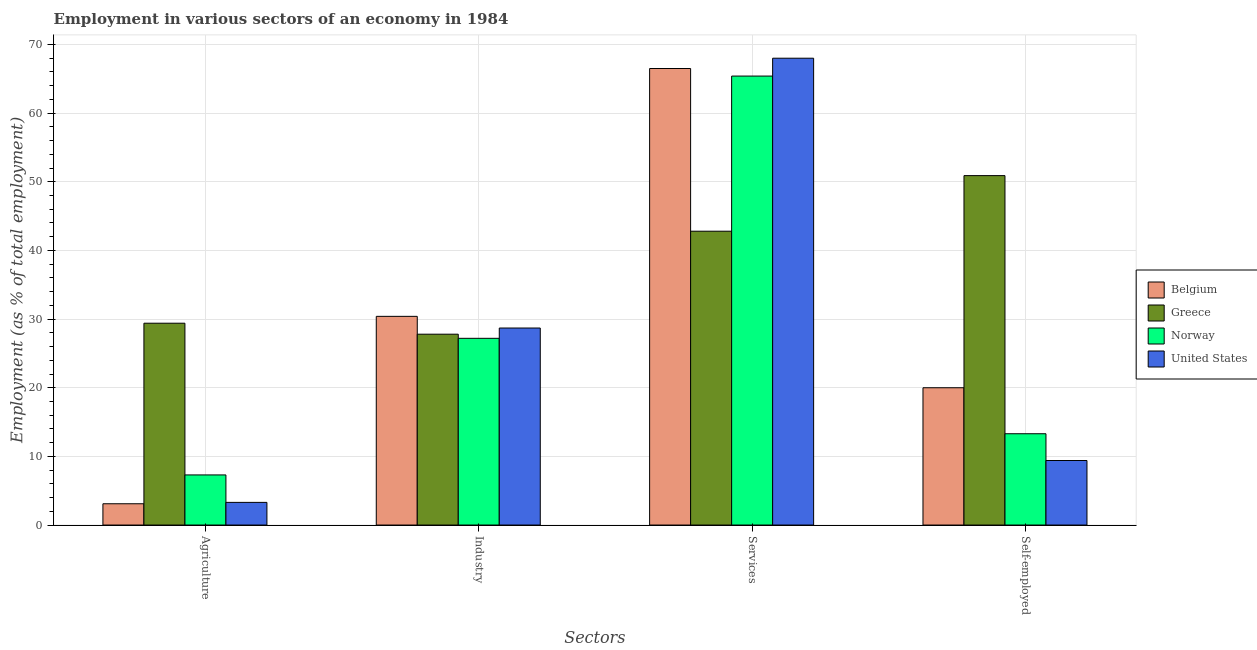How many different coloured bars are there?
Provide a succinct answer. 4. How many groups of bars are there?
Give a very brief answer. 4. Are the number of bars on each tick of the X-axis equal?
Your response must be concise. Yes. What is the label of the 2nd group of bars from the left?
Your answer should be compact. Industry. What is the percentage of workers in industry in Norway?
Your answer should be compact. 27.2. Across all countries, what is the maximum percentage of workers in industry?
Your answer should be compact. 30.4. Across all countries, what is the minimum percentage of self employed workers?
Your answer should be compact. 9.4. In which country was the percentage of workers in agriculture maximum?
Provide a succinct answer. Greece. In which country was the percentage of self employed workers minimum?
Provide a succinct answer. United States. What is the total percentage of workers in industry in the graph?
Your answer should be compact. 114.1. What is the difference between the percentage of workers in services in United States and that in Greece?
Keep it short and to the point. 25.2. What is the difference between the percentage of workers in industry in Norway and the percentage of workers in services in United States?
Your response must be concise. -40.8. What is the average percentage of workers in services per country?
Your response must be concise. 60.68. What is the difference between the percentage of workers in agriculture and percentage of workers in services in Norway?
Give a very brief answer. -58.1. What is the ratio of the percentage of workers in services in United States to that in Greece?
Provide a short and direct response. 1.59. Is the difference between the percentage of workers in agriculture in Norway and United States greater than the difference between the percentage of workers in services in Norway and United States?
Your response must be concise. Yes. What is the difference between the highest and the second highest percentage of workers in agriculture?
Keep it short and to the point. 22.1. What is the difference between the highest and the lowest percentage of workers in services?
Make the answer very short. 25.2. In how many countries, is the percentage of workers in agriculture greater than the average percentage of workers in agriculture taken over all countries?
Offer a terse response. 1. Is the sum of the percentage of workers in agriculture in United States and Norway greater than the maximum percentage of workers in services across all countries?
Give a very brief answer. No. What does the 2nd bar from the left in Agriculture represents?
Ensure brevity in your answer.  Greece. Is it the case that in every country, the sum of the percentage of workers in agriculture and percentage of workers in industry is greater than the percentage of workers in services?
Your answer should be very brief. No. Are all the bars in the graph horizontal?
Give a very brief answer. No. What is the difference between two consecutive major ticks on the Y-axis?
Keep it short and to the point. 10. Are the values on the major ticks of Y-axis written in scientific E-notation?
Offer a very short reply. No. Does the graph contain grids?
Offer a very short reply. Yes. Where does the legend appear in the graph?
Ensure brevity in your answer.  Center right. How many legend labels are there?
Your answer should be very brief. 4. What is the title of the graph?
Provide a short and direct response. Employment in various sectors of an economy in 1984. Does "Nicaragua" appear as one of the legend labels in the graph?
Your answer should be compact. No. What is the label or title of the X-axis?
Ensure brevity in your answer.  Sectors. What is the label or title of the Y-axis?
Offer a terse response. Employment (as % of total employment). What is the Employment (as % of total employment) in Belgium in Agriculture?
Provide a succinct answer. 3.1. What is the Employment (as % of total employment) in Greece in Agriculture?
Ensure brevity in your answer.  29.4. What is the Employment (as % of total employment) of Norway in Agriculture?
Your answer should be very brief. 7.3. What is the Employment (as % of total employment) in United States in Agriculture?
Provide a succinct answer. 3.3. What is the Employment (as % of total employment) of Belgium in Industry?
Your answer should be very brief. 30.4. What is the Employment (as % of total employment) of Greece in Industry?
Keep it short and to the point. 27.8. What is the Employment (as % of total employment) of Norway in Industry?
Provide a succinct answer. 27.2. What is the Employment (as % of total employment) of United States in Industry?
Make the answer very short. 28.7. What is the Employment (as % of total employment) in Belgium in Services?
Provide a succinct answer. 66.5. What is the Employment (as % of total employment) of Greece in Services?
Provide a succinct answer. 42.8. What is the Employment (as % of total employment) of Norway in Services?
Your answer should be compact. 65.4. What is the Employment (as % of total employment) in United States in Services?
Your response must be concise. 68. What is the Employment (as % of total employment) of Belgium in Self-employed?
Give a very brief answer. 20. What is the Employment (as % of total employment) of Greece in Self-employed?
Make the answer very short. 50.9. What is the Employment (as % of total employment) of Norway in Self-employed?
Your answer should be very brief. 13.3. What is the Employment (as % of total employment) of United States in Self-employed?
Provide a succinct answer. 9.4. Across all Sectors, what is the maximum Employment (as % of total employment) of Belgium?
Give a very brief answer. 66.5. Across all Sectors, what is the maximum Employment (as % of total employment) of Greece?
Make the answer very short. 50.9. Across all Sectors, what is the maximum Employment (as % of total employment) of Norway?
Your answer should be very brief. 65.4. Across all Sectors, what is the minimum Employment (as % of total employment) of Belgium?
Ensure brevity in your answer.  3.1. Across all Sectors, what is the minimum Employment (as % of total employment) of Greece?
Offer a terse response. 27.8. Across all Sectors, what is the minimum Employment (as % of total employment) in Norway?
Offer a terse response. 7.3. Across all Sectors, what is the minimum Employment (as % of total employment) of United States?
Offer a terse response. 3.3. What is the total Employment (as % of total employment) of Belgium in the graph?
Ensure brevity in your answer.  120. What is the total Employment (as % of total employment) of Greece in the graph?
Provide a succinct answer. 150.9. What is the total Employment (as % of total employment) in Norway in the graph?
Your response must be concise. 113.2. What is the total Employment (as % of total employment) in United States in the graph?
Make the answer very short. 109.4. What is the difference between the Employment (as % of total employment) of Belgium in Agriculture and that in Industry?
Offer a very short reply. -27.3. What is the difference between the Employment (as % of total employment) of Norway in Agriculture and that in Industry?
Your response must be concise. -19.9. What is the difference between the Employment (as % of total employment) of United States in Agriculture and that in Industry?
Your answer should be very brief. -25.4. What is the difference between the Employment (as % of total employment) in Belgium in Agriculture and that in Services?
Provide a succinct answer. -63.4. What is the difference between the Employment (as % of total employment) of Greece in Agriculture and that in Services?
Your answer should be very brief. -13.4. What is the difference between the Employment (as % of total employment) in Norway in Agriculture and that in Services?
Your response must be concise. -58.1. What is the difference between the Employment (as % of total employment) of United States in Agriculture and that in Services?
Provide a short and direct response. -64.7. What is the difference between the Employment (as % of total employment) in Belgium in Agriculture and that in Self-employed?
Give a very brief answer. -16.9. What is the difference between the Employment (as % of total employment) in Greece in Agriculture and that in Self-employed?
Offer a terse response. -21.5. What is the difference between the Employment (as % of total employment) in Belgium in Industry and that in Services?
Your response must be concise. -36.1. What is the difference between the Employment (as % of total employment) of Norway in Industry and that in Services?
Keep it short and to the point. -38.2. What is the difference between the Employment (as % of total employment) in United States in Industry and that in Services?
Ensure brevity in your answer.  -39.3. What is the difference between the Employment (as % of total employment) in Belgium in Industry and that in Self-employed?
Offer a very short reply. 10.4. What is the difference between the Employment (as % of total employment) of Greece in Industry and that in Self-employed?
Your answer should be compact. -23.1. What is the difference between the Employment (as % of total employment) of Norway in Industry and that in Self-employed?
Offer a very short reply. 13.9. What is the difference between the Employment (as % of total employment) in United States in Industry and that in Self-employed?
Provide a succinct answer. 19.3. What is the difference between the Employment (as % of total employment) of Belgium in Services and that in Self-employed?
Give a very brief answer. 46.5. What is the difference between the Employment (as % of total employment) in Norway in Services and that in Self-employed?
Provide a succinct answer. 52.1. What is the difference between the Employment (as % of total employment) in United States in Services and that in Self-employed?
Keep it short and to the point. 58.6. What is the difference between the Employment (as % of total employment) in Belgium in Agriculture and the Employment (as % of total employment) in Greece in Industry?
Offer a terse response. -24.7. What is the difference between the Employment (as % of total employment) of Belgium in Agriculture and the Employment (as % of total employment) of Norway in Industry?
Make the answer very short. -24.1. What is the difference between the Employment (as % of total employment) in Belgium in Agriculture and the Employment (as % of total employment) in United States in Industry?
Offer a terse response. -25.6. What is the difference between the Employment (as % of total employment) in Norway in Agriculture and the Employment (as % of total employment) in United States in Industry?
Ensure brevity in your answer.  -21.4. What is the difference between the Employment (as % of total employment) in Belgium in Agriculture and the Employment (as % of total employment) in Greece in Services?
Provide a short and direct response. -39.7. What is the difference between the Employment (as % of total employment) of Belgium in Agriculture and the Employment (as % of total employment) of Norway in Services?
Your answer should be very brief. -62.3. What is the difference between the Employment (as % of total employment) in Belgium in Agriculture and the Employment (as % of total employment) in United States in Services?
Give a very brief answer. -64.9. What is the difference between the Employment (as % of total employment) of Greece in Agriculture and the Employment (as % of total employment) of Norway in Services?
Make the answer very short. -36. What is the difference between the Employment (as % of total employment) in Greece in Agriculture and the Employment (as % of total employment) in United States in Services?
Keep it short and to the point. -38.6. What is the difference between the Employment (as % of total employment) in Norway in Agriculture and the Employment (as % of total employment) in United States in Services?
Give a very brief answer. -60.7. What is the difference between the Employment (as % of total employment) of Belgium in Agriculture and the Employment (as % of total employment) of Greece in Self-employed?
Keep it short and to the point. -47.8. What is the difference between the Employment (as % of total employment) in Belgium in Agriculture and the Employment (as % of total employment) in United States in Self-employed?
Provide a short and direct response. -6.3. What is the difference between the Employment (as % of total employment) of Greece in Agriculture and the Employment (as % of total employment) of Norway in Self-employed?
Give a very brief answer. 16.1. What is the difference between the Employment (as % of total employment) of Norway in Agriculture and the Employment (as % of total employment) of United States in Self-employed?
Your answer should be very brief. -2.1. What is the difference between the Employment (as % of total employment) in Belgium in Industry and the Employment (as % of total employment) in Greece in Services?
Offer a very short reply. -12.4. What is the difference between the Employment (as % of total employment) of Belgium in Industry and the Employment (as % of total employment) of Norway in Services?
Offer a very short reply. -35. What is the difference between the Employment (as % of total employment) in Belgium in Industry and the Employment (as % of total employment) in United States in Services?
Provide a succinct answer. -37.6. What is the difference between the Employment (as % of total employment) in Greece in Industry and the Employment (as % of total employment) in Norway in Services?
Your answer should be compact. -37.6. What is the difference between the Employment (as % of total employment) in Greece in Industry and the Employment (as % of total employment) in United States in Services?
Ensure brevity in your answer.  -40.2. What is the difference between the Employment (as % of total employment) of Norway in Industry and the Employment (as % of total employment) of United States in Services?
Keep it short and to the point. -40.8. What is the difference between the Employment (as % of total employment) of Belgium in Industry and the Employment (as % of total employment) of Greece in Self-employed?
Ensure brevity in your answer.  -20.5. What is the difference between the Employment (as % of total employment) in Greece in Industry and the Employment (as % of total employment) in Norway in Self-employed?
Give a very brief answer. 14.5. What is the difference between the Employment (as % of total employment) of Belgium in Services and the Employment (as % of total employment) of Norway in Self-employed?
Keep it short and to the point. 53.2. What is the difference between the Employment (as % of total employment) in Belgium in Services and the Employment (as % of total employment) in United States in Self-employed?
Your answer should be very brief. 57.1. What is the difference between the Employment (as % of total employment) of Greece in Services and the Employment (as % of total employment) of Norway in Self-employed?
Your answer should be compact. 29.5. What is the difference between the Employment (as % of total employment) in Greece in Services and the Employment (as % of total employment) in United States in Self-employed?
Provide a succinct answer. 33.4. What is the average Employment (as % of total employment) in Belgium per Sectors?
Ensure brevity in your answer.  30. What is the average Employment (as % of total employment) in Greece per Sectors?
Offer a very short reply. 37.73. What is the average Employment (as % of total employment) in Norway per Sectors?
Your answer should be very brief. 28.3. What is the average Employment (as % of total employment) in United States per Sectors?
Provide a short and direct response. 27.35. What is the difference between the Employment (as % of total employment) in Belgium and Employment (as % of total employment) in Greece in Agriculture?
Offer a terse response. -26.3. What is the difference between the Employment (as % of total employment) in Belgium and Employment (as % of total employment) in United States in Agriculture?
Ensure brevity in your answer.  -0.2. What is the difference between the Employment (as % of total employment) of Greece and Employment (as % of total employment) of Norway in Agriculture?
Give a very brief answer. 22.1. What is the difference between the Employment (as % of total employment) in Greece and Employment (as % of total employment) in United States in Agriculture?
Ensure brevity in your answer.  26.1. What is the difference between the Employment (as % of total employment) in Norway and Employment (as % of total employment) in United States in Agriculture?
Your response must be concise. 4. What is the difference between the Employment (as % of total employment) in Belgium and Employment (as % of total employment) in Greece in Industry?
Your answer should be very brief. 2.6. What is the difference between the Employment (as % of total employment) of Belgium and Employment (as % of total employment) of Norway in Industry?
Offer a very short reply. 3.2. What is the difference between the Employment (as % of total employment) in Belgium and Employment (as % of total employment) in Greece in Services?
Make the answer very short. 23.7. What is the difference between the Employment (as % of total employment) in Greece and Employment (as % of total employment) in Norway in Services?
Your answer should be compact. -22.6. What is the difference between the Employment (as % of total employment) in Greece and Employment (as % of total employment) in United States in Services?
Your answer should be very brief. -25.2. What is the difference between the Employment (as % of total employment) in Belgium and Employment (as % of total employment) in Greece in Self-employed?
Offer a very short reply. -30.9. What is the difference between the Employment (as % of total employment) of Belgium and Employment (as % of total employment) of Norway in Self-employed?
Offer a very short reply. 6.7. What is the difference between the Employment (as % of total employment) in Belgium and Employment (as % of total employment) in United States in Self-employed?
Offer a very short reply. 10.6. What is the difference between the Employment (as % of total employment) in Greece and Employment (as % of total employment) in Norway in Self-employed?
Offer a terse response. 37.6. What is the difference between the Employment (as % of total employment) of Greece and Employment (as % of total employment) of United States in Self-employed?
Provide a succinct answer. 41.5. What is the difference between the Employment (as % of total employment) in Norway and Employment (as % of total employment) in United States in Self-employed?
Make the answer very short. 3.9. What is the ratio of the Employment (as % of total employment) of Belgium in Agriculture to that in Industry?
Your answer should be very brief. 0.1. What is the ratio of the Employment (as % of total employment) in Greece in Agriculture to that in Industry?
Keep it short and to the point. 1.06. What is the ratio of the Employment (as % of total employment) of Norway in Agriculture to that in Industry?
Ensure brevity in your answer.  0.27. What is the ratio of the Employment (as % of total employment) of United States in Agriculture to that in Industry?
Offer a very short reply. 0.12. What is the ratio of the Employment (as % of total employment) of Belgium in Agriculture to that in Services?
Ensure brevity in your answer.  0.05. What is the ratio of the Employment (as % of total employment) in Greece in Agriculture to that in Services?
Offer a very short reply. 0.69. What is the ratio of the Employment (as % of total employment) in Norway in Agriculture to that in Services?
Your answer should be very brief. 0.11. What is the ratio of the Employment (as % of total employment) of United States in Agriculture to that in Services?
Make the answer very short. 0.05. What is the ratio of the Employment (as % of total employment) of Belgium in Agriculture to that in Self-employed?
Offer a very short reply. 0.15. What is the ratio of the Employment (as % of total employment) of Greece in Agriculture to that in Self-employed?
Offer a terse response. 0.58. What is the ratio of the Employment (as % of total employment) in Norway in Agriculture to that in Self-employed?
Keep it short and to the point. 0.55. What is the ratio of the Employment (as % of total employment) in United States in Agriculture to that in Self-employed?
Offer a terse response. 0.35. What is the ratio of the Employment (as % of total employment) in Belgium in Industry to that in Services?
Give a very brief answer. 0.46. What is the ratio of the Employment (as % of total employment) of Greece in Industry to that in Services?
Provide a short and direct response. 0.65. What is the ratio of the Employment (as % of total employment) of Norway in Industry to that in Services?
Offer a very short reply. 0.42. What is the ratio of the Employment (as % of total employment) in United States in Industry to that in Services?
Make the answer very short. 0.42. What is the ratio of the Employment (as % of total employment) in Belgium in Industry to that in Self-employed?
Provide a succinct answer. 1.52. What is the ratio of the Employment (as % of total employment) in Greece in Industry to that in Self-employed?
Keep it short and to the point. 0.55. What is the ratio of the Employment (as % of total employment) of Norway in Industry to that in Self-employed?
Give a very brief answer. 2.05. What is the ratio of the Employment (as % of total employment) in United States in Industry to that in Self-employed?
Provide a succinct answer. 3.05. What is the ratio of the Employment (as % of total employment) of Belgium in Services to that in Self-employed?
Keep it short and to the point. 3.33. What is the ratio of the Employment (as % of total employment) of Greece in Services to that in Self-employed?
Give a very brief answer. 0.84. What is the ratio of the Employment (as % of total employment) in Norway in Services to that in Self-employed?
Offer a very short reply. 4.92. What is the ratio of the Employment (as % of total employment) of United States in Services to that in Self-employed?
Offer a terse response. 7.23. What is the difference between the highest and the second highest Employment (as % of total employment) of Belgium?
Make the answer very short. 36.1. What is the difference between the highest and the second highest Employment (as % of total employment) of Greece?
Your answer should be very brief. 8.1. What is the difference between the highest and the second highest Employment (as % of total employment) in Norway?
Your answer should be compact. 38.2. What is the difference between the highest and the second highest Employment (as % of total employment) of United States?
Offer a terse response. 39.3. What is the difference between the highest and the lowest Employment (as % of total employment) in Belgium?
Offer a terse response. 63.4. What is the difference between the highest and the lowest Employment (as % of total employment) in Greece?
Offer a very short reply. 23.1. What is the difference between the highest and the lowest Employment (as % of total employment) in Norway?
Offer a terse response. 58.1. What is the difference between the highest and the lowest Employment (as % of total employment) in United States?
Provide a short and direct response. 64.7. 